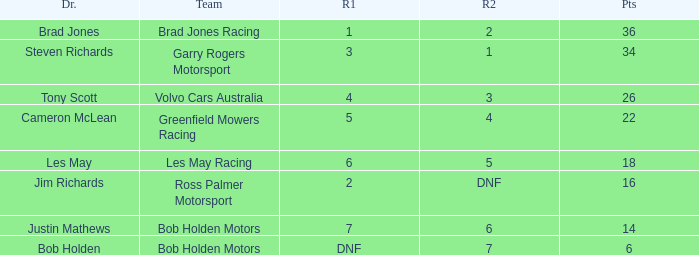Which driver for Bob Holden Motors has fewer than 36 points and placed 7 in race 1? Justin Mathews. 